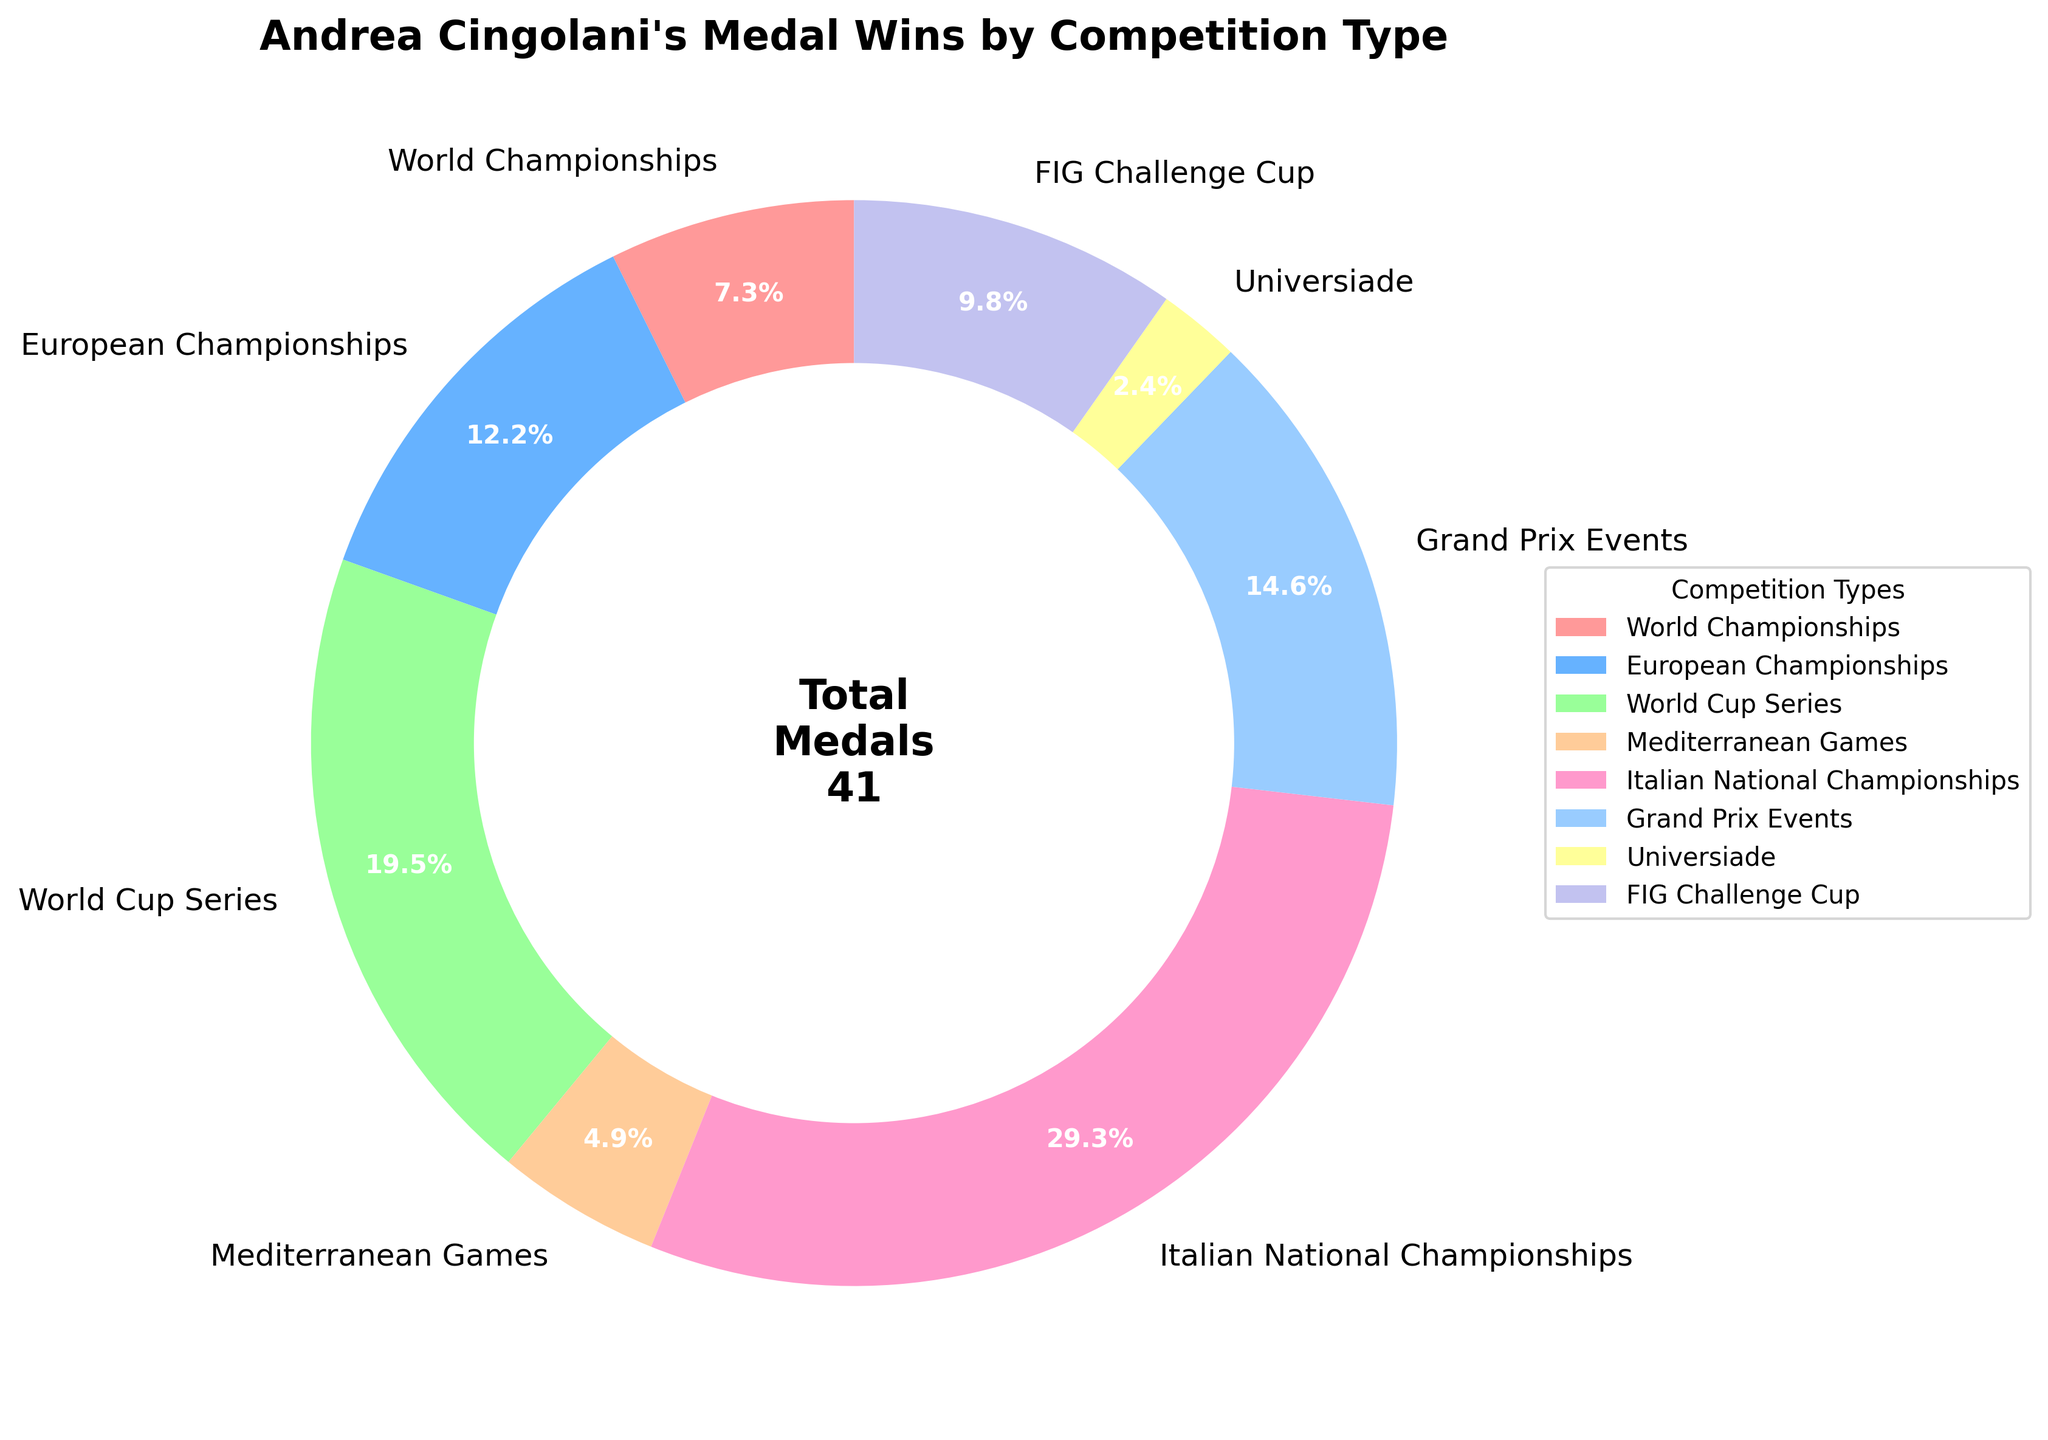Which competition type has the highest percentage of Andrea Cingolani's medal wins? By observing the pie chart, the largest segment can be identified. The "Italian National Championships" segment is the largest, indicating the highest percentage.
Answer: Italian National Championships How many more medals has Andrea won at the World Cup Series compared to the Mediterranean Games? From the chart, World Cup Series has 8 medals and Mediterranean Games has 2 medals. The difference is calculated as 8 - 2.
Answer: 6 Which competition type's segment is depicted in red? By referring to the segment colors in the chart, the red segment corresponds to Mediterranean Games.
Answer: Mediterranean Games What is the total number of medals won at Grand Prix Events and FIG Challenge Cup? Grand Prix Events has 6 medals and FIG Challenge Cup has 4 medals, their sum is 6 + 4.
Answer: 10 Which two competitions have an equal number of medal wins? Observing the pie chart, it is evident that no two segments are equal in size, implying that no two competitions have the same number of medal wins.
Answer: None Is Andrea's total medal count at World Championships twice that of the Universiade? World Championships: 3 medals, Universiade: 1 medal. Checking 3 equals 2 * 1 confirms this.
Answer: Yes Which competition type has a segment that is closest in size to European Championships? To find the segment size close to European Championships (5 medals), we compare other segments, and Grand Prix Events with 6 medals is the closest.
Answer: Grand Prix Events What percentage of Andrea's total medals were won at the World Cup Series? World Cup Series has 8 medals out of a total of 41 medals. Calculating the percentage: (8 / 41) * 100.
Answer: 19.5% Which segment indicates the least number of medals won, and what is the number? The smallest pie segment is Universiade, which represents 1 medal.
Answer: Universiade, 1 How does the sum of medals from the European Championships and FIG Challenge Cup compare to the Italian National Championships? European Championships: 5 medals, FIG Challenge Cup: 4 medals; their sum is 5 + 4 = 9. Italian National Championships has 12 medals, and 9 is less than 12.
Answer: Less 